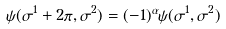<formula> <loc_0><loc_0><loc_500><loc_500>\psi ( \sigma ^ { 1 } + 2 \pi , \sigma ^ { 2 } ) = ( - 1 ) ^ { \alpha } \psi ( \sigma ^ { 1 } , \sigma ^ { 2 } )</formula> 